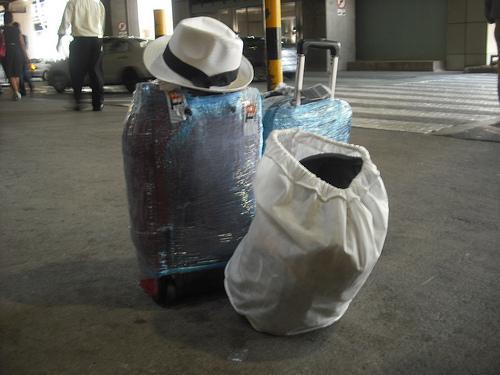How many bags are there?
Give a very brief answer. 3. 